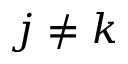Convert formula to latex. <formula><loc_0><loc_0><loc_500><loc_500>j \neq k</formula> 